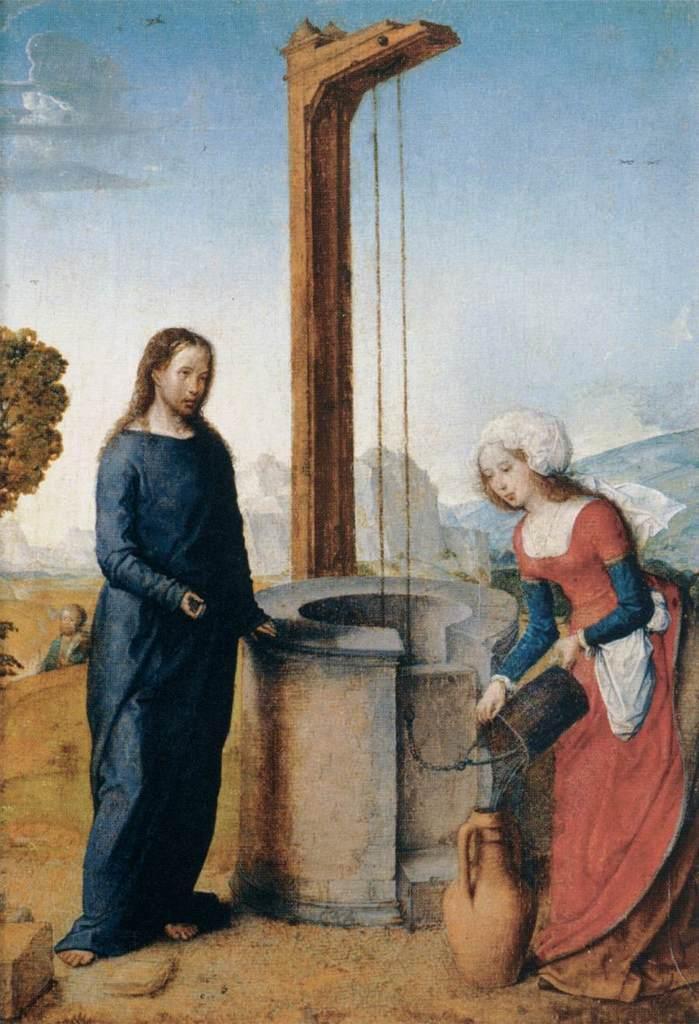In one or two sentences, can you explain what this image depicts? In this image there are people. The lady standing on the right is holding a bucket. At the bottom there is a vase. On the left there is a tree. In the background there are hills and sky. In the center there is a well. 